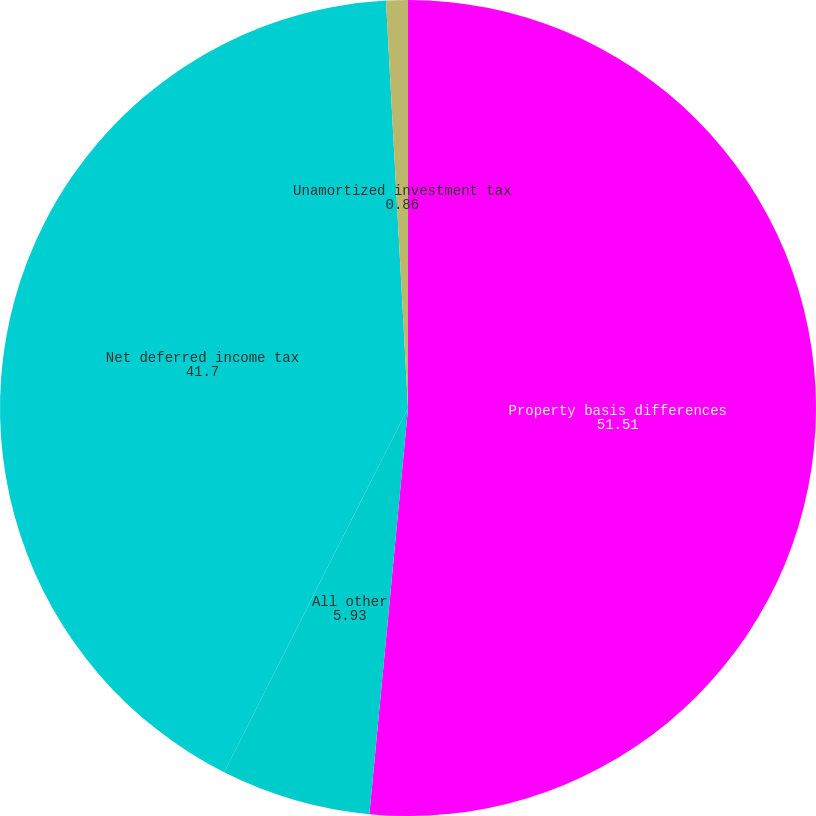<chart> <loc_0><loc_0><loc_500><loc_500><pie_chart><fcel>Property basis differences<fcel>All other<fcel>Net deferred income tax<fcel>Unamortized investment tax<nl><fcel>51.51%<fcel>5.93%<fcel>41.7%<fcel>0.86%<nl></chart> 